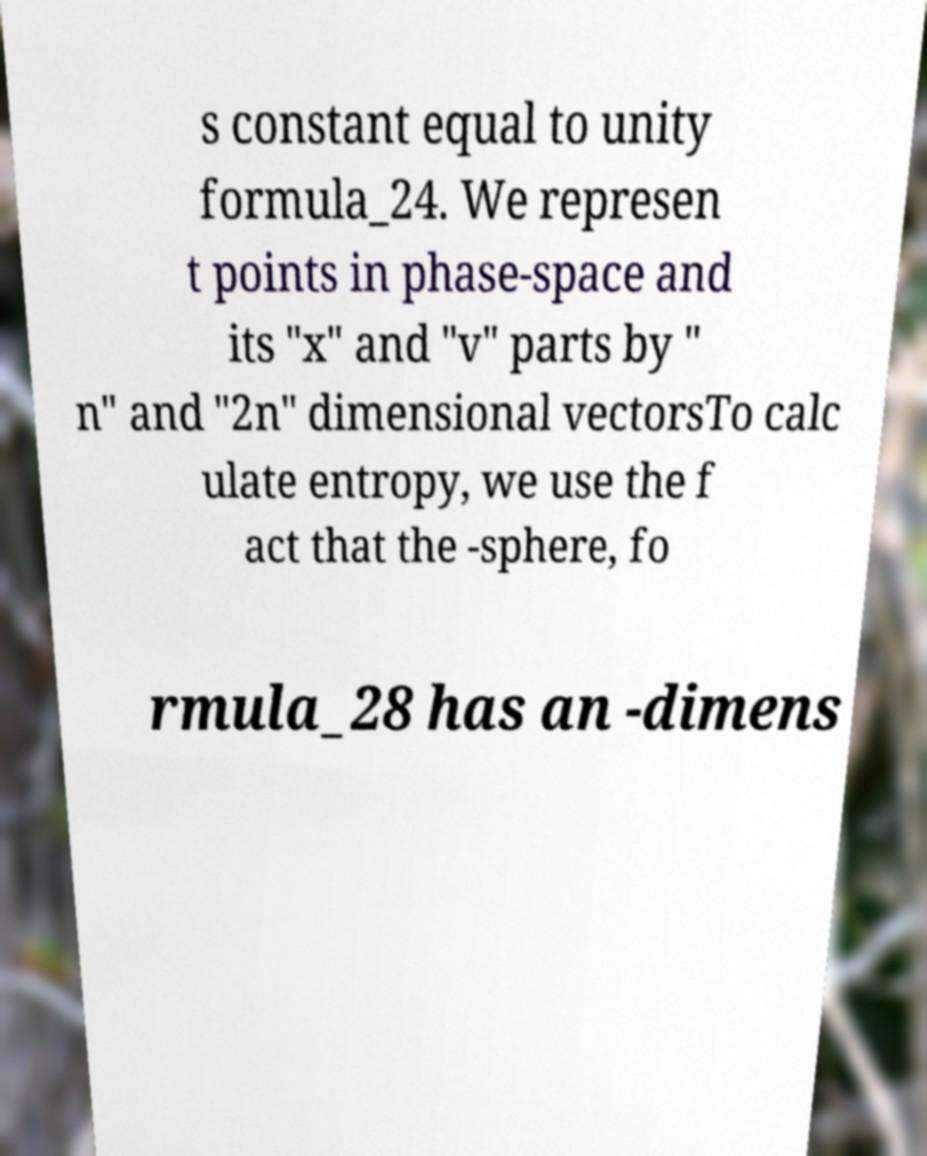What messages or text are displayed in this image? I need them in a readable, typed format. s constant equal to unity formula_24. We represen t points in phase-space and its "x" and "v" parts by " n" and "2n" dimensional vectorsTo calc ulate entropy, we use the f act that the -sphere, fo rmula_28 has an -dimens 